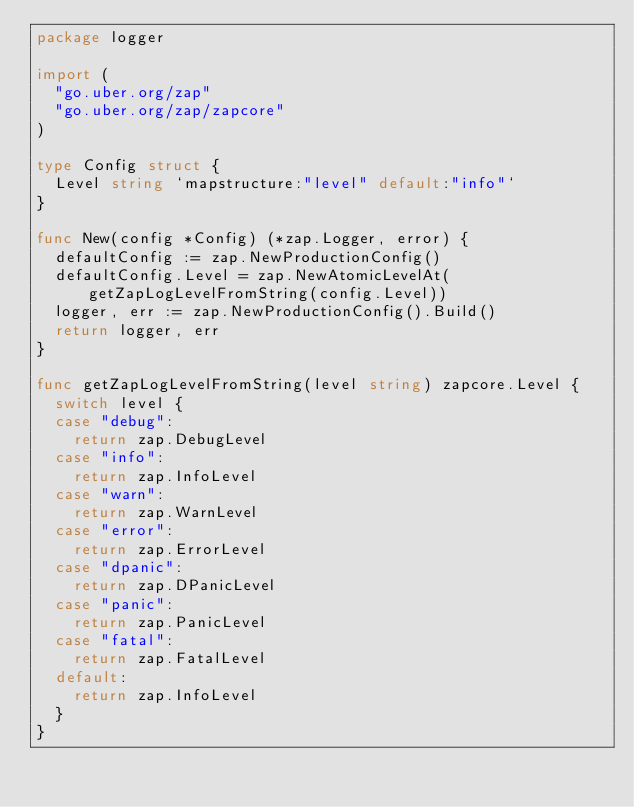<code> <loc_0><loc_0><loc_500><loc_500><_Go_>package logger

import (
	"go.uber.org/zap"
	"go.uber.org/zap/zapcore"
)

type Config struct {
	Level string `mapstructure:"level" default:"info"`
}

func New(config *Config) (*zap.Logger, error) {
	defaultConfig := zap.NewProductionConfig()
	defaultConfig.Level = zap.NewAtomicLevelAt(getZapLogLevelFromString(config.Level))
	logger, err := zap.NewProductionConfig().Build()
	return logger, err
}

func getZapLogLevelFromString(level string) zapcore.Level {
	switch level {
	case "debug":
		return zap.DebugLevel
	case "info":
		return zap.InfoLevel
	case "warn":
		return zap.WarnLevel
	case "error":
		return zap.ErrorLevel
	case "dpanic":
		return zap.DPanicLevel
	case "panic":
		return zap.PanicLevel
	case "fatal":
		return zap.FatalLevel
	default:
		return zap.InfoLevel
	}
}
</code> 